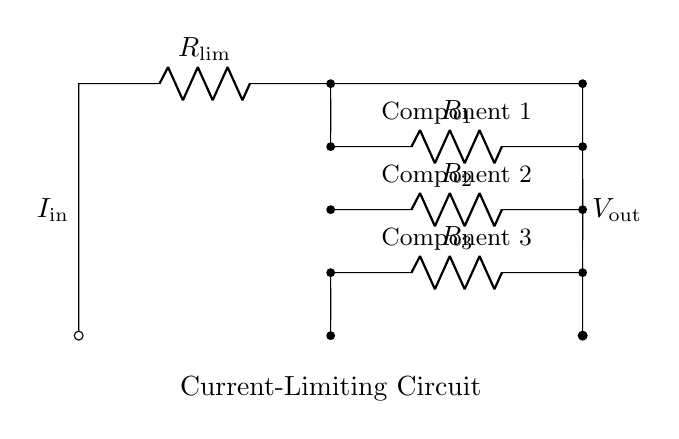What is the value of the limiting resistor? The limiting resistor is labeled as R_lim in the circuit diagram and is a key component that controls the current flowing into the parallel branches.
Answer: R_lim How many resistors are in parallel? Three resistors, R_1, R_2, and R_3, are shown connected in parallel, as indicated by their layout in the circuit diagram.
Answer: Three What current is entering the circuit? The input current is denoted as I_in, which is the total current supplied to the circuit from the source before dividing among the branches.
Answer: I_in Which resistor will have the highest current? The resistor with the lowest resistance value among R_1, R_2, and R_3 will have the highest current through it due to Ohm's law, as current divides inversely proportional to resistance.
Answer: R with least value How does the current split among the parallel resistors? Current divides among parallel resistors inversely based on their resistance values. Each branch receives a portion of the total current larger than proportionately smaller resistances.
Answer: Inversely proportional What is the output voltage of the circuit? The output voltage V_out is the same across all parallel branches connected directly to the input of the limiting resistor, as they are connected in parallel.
Answer: Same as input voltage What is the purpose of the current-limiting resistor? The current-limiting resistor R_lim is used to prevent excessive current from flowing through the parallel component branches, thus protecting them from potential damage due to overcurrent.
Answer: To limit current 